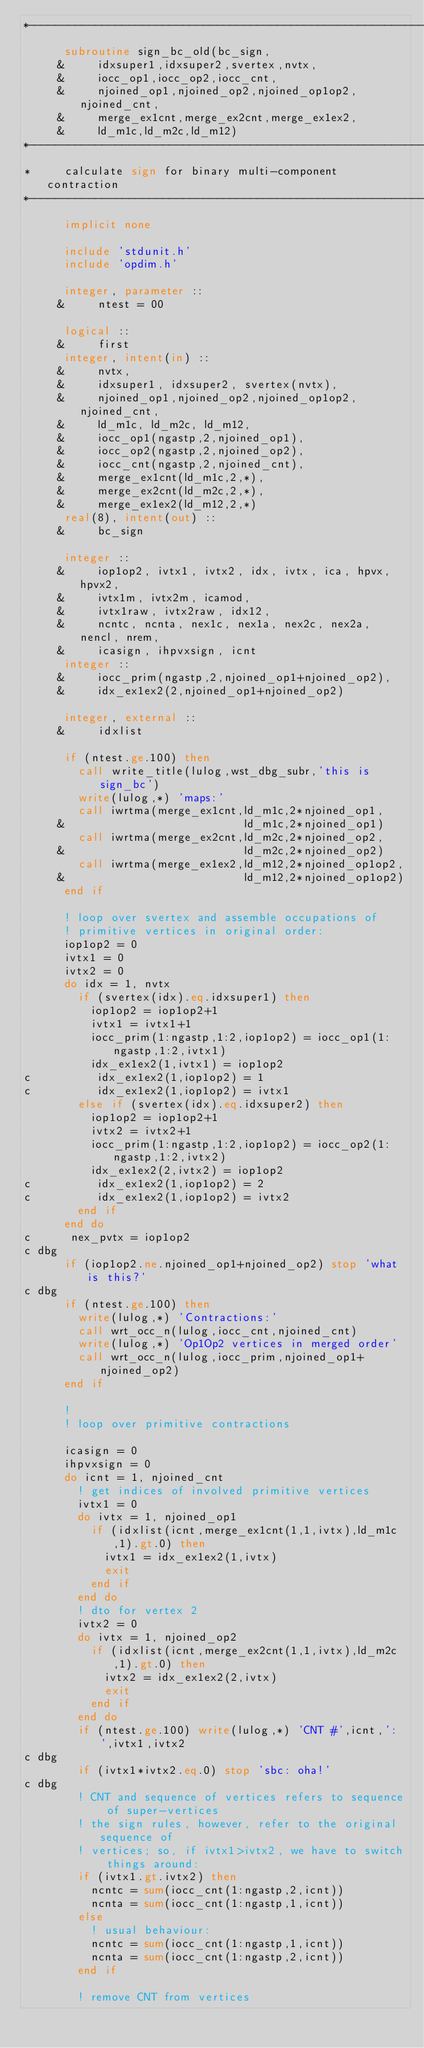Convert code to text. <code><loc_0><loc_0><loc_500><loc_500><_FORTRAN_>*----------------------------------------------------------------------*
      subroutine sign_bc_old(bc_sign,
     &     idxsuper1,idxsuper2,svertex,nvtx,
     &     iocc_op1,iocc_op2,iocc_cnt,
     &     njoined_op1,njoined_op2,njoined_op1op2,njoined_cnt,
     &     merge_ex1cnt,merge_ex2cnt,merge_ex1ex2,
     &     ld_m1c,ld_m2c,ld_m12)
*----------------------------------------------------------------------*
*     calculate sign for binary multi-component contraction
*----------------------------------------------------------------------*
      implicit none

      include 'stdunit.h'
      include 'opdim.h'

      integer, parameter ::
     &     ntest = 00

      logical ::
     &     first
      integer, intent(in) ::
     &     nvtx,
     &     idxsuper1, idxsuper2, svertex(nvtx),
     &     njoined_op1,njoined_op2,njoined_op1op2,njoined_cnt,
     &     ld_m1c, ld_m2c, ld_m12, 
     &     iocc_op1(ngastp,2,njoined_op1),
     &     iocc_op2(ngastp,2,njoined_op2),
     &     iocc_cnt(ngastp,2,njoined_cnt),
     &     merge_ex1cnt(ld_m1c,2,*),
     &     merge_ex2cnt(ld_m2c,2,*),
     &     merge_ex1ex2(ld_m12,2,*)
      real(8), intent(out) ::
     &     bc_sign

      integer ::
     &     iop1op2, ivtx1, ivtx2, idx, ivtx, ica, hpvx, hpvx2,
     &     ivtx1m, ivtx2m, icamod,
     &     ivtx1raw, ivtx2raw, idx12,
     &     ncntc, ncnta, nex1c, nex1a, nex2c, nex2a, nencl, nrem,
     &     icasign, ihpvxsign, icnt
      integer ::
     &     iocc_prim(ngastp,2,njoined_op1+njoined_op2),
     &     idx_ex1ex2(2,njoined_op1+njoined_op2)

      integer, external ::
     &     idxlist

      if (ntest.ge.100) then
        call write_title(lulog,wst_dbg_subr,'this is sign_bc')
        write(lulog,*) 'maps:'
        call iwrtma(merge_ex1cnt,ld_m1c,2*njoined_op1,
     &                           ld_m1c,2*njoined_op1)
        call iwrtma(merge_ex2cnt,ld_m2c,2*njoined_op2,
     &                           ld_m2c,2*njoined_op2)
        call iwrtma(merge_ex1ex2,ld_m12,2*njoined_op1op2,
     &                           ld_m12,2*njoined_op1op2)
      end if

      ! loop over svertex and assemble occupations of
      ! primitive vertices in original order:
      iop1op2 = 0
      ivtx1 = 0
      ivtx2 = 0
      do idx = 1, nvtx
        if (svertex(idx).eq.idxsuper1) then
          iop1op2 = iop1op2+1
          ivtx1 = ivtx1+1
          iocc_prim(1:ngastp,1:2,iop1op2) = iocc_op1(1:ngastp,1:2,ivtx1)
          idx_ex1ex2(1,ivtx1) = iop1op2
c          idx_ex1ex2(1,iop1op2) = 1
c          idx_ex1ex2(1,iop1op2) = ivtx1
        else if (svertex(idx).eq.idxsuper2) then
          iop1op2 = iop1op2+1
          ivtx2 = ivtx2+1
          iocc_prim(1:ngastp,1:2,iop1op2) = iocc_op2(1:ngastp,1:2,ivtx2)
          idx_ex1ex2(2,ivtx2) = iop1op2
c          idx_ex1ex2(1,iop1op2) = 2
c          idx_ex1ex2(1,iop1op2) = ivtx2
        end if
      end do
c      nex_pvtx = iop1op2
c dbg
      if (iop1op2.ne.njoined_op1+njoined_op2) stop 'what is this?'
c dbg
      if (ntest.ge.100) then
        write(lulog,*) 'Contractions:'
        call wrt_occ_n(lulog,iocc_cnt,njoined_cnt)
        write(lulog,*) 'Op1Op2 vertices in merged order'
        call wrt_occ_n(lulog,iocc_prim,njoined_op1+njoined_op2)
      end if

      ! 
      ! loop over primitive contractions

      icasign = 0
      ihpvxsign = 0
      do icnt = 1, njoined_cnt
        ! get indices of involved primitive vertices
        ivtx1 = 0
        do ivtx = 1, njoined_op1
          if (idxlist(icnt,merge_ex1cnt(1,1,ivtx),ld_m1c,1).gt.0) then
            ivtx1 = idx_ex1ex2(1,ivtx)
            exit
          end if
        end do
        ! dto for vertex 2
        ivtx2 = 0
        do ivtx = 1, njoined_op2
          if (idxlist(icnt,merge_ex2cnt(1,1,ivtx),ld_m2c,1).gt.0) then
            ivtx2 = idx_ex1ex2(2,ivtx)
            exit
          end if
        end do
        if (ntest.ge.100) write(lulog,*) 'CNT #',icnt,': ',ivtx1,ivtx2
c dbg
        if (ivtx1*ivtx2.eq.0) stop 'sbc: oha!'
c dbg
        ! CNT and sequence of vertices refers to sequence of super-vertices
        ! the sign rules, however, refer to the original sequence of
        ! vertices; so, if ivtx1>ivtx2, we have to switch things around:
        if (ivtx1.gt.ivtx2) then
          ncntc = sum(iocc_cnt(1:ngastp,2,icnt))
          ncnta = sum(iocc_cnt(1:ngastp,1,icnt))
        else
          ! usual behaviour:
          ncntc = sum(iocc_cnt(1:ngastp,1,icnt))
          ncnta = sum(iocc_cnt(1:ngastp,2,icnt))
        end if

        ! remove CNT from vertices</code> 